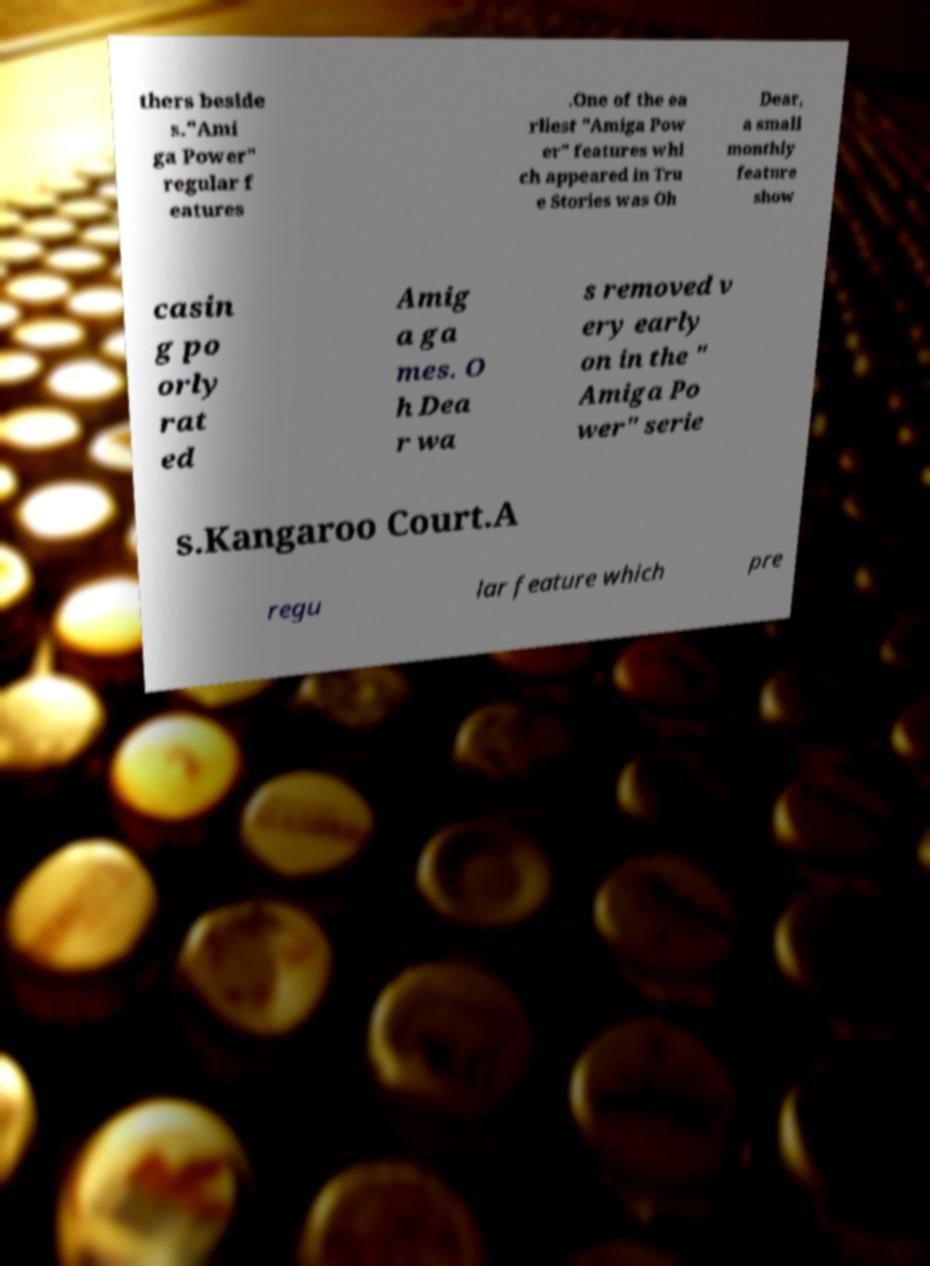For documentation purposes, I need the text within this image transcribed. Could you provide that? thers beside s."Ami ga Power" regular f eatures .One of the ea rliest "Amiga Pow er" features whi ch appeared in Tru e Stories was Oh Dear, a small monthly feature show casin g po orly rat ed Amig a ga mes. O h Dea r wa s removed v ery early on in the " Amiga Po wer" serie s.Kangaroo Court.A regu lar feature which pre 